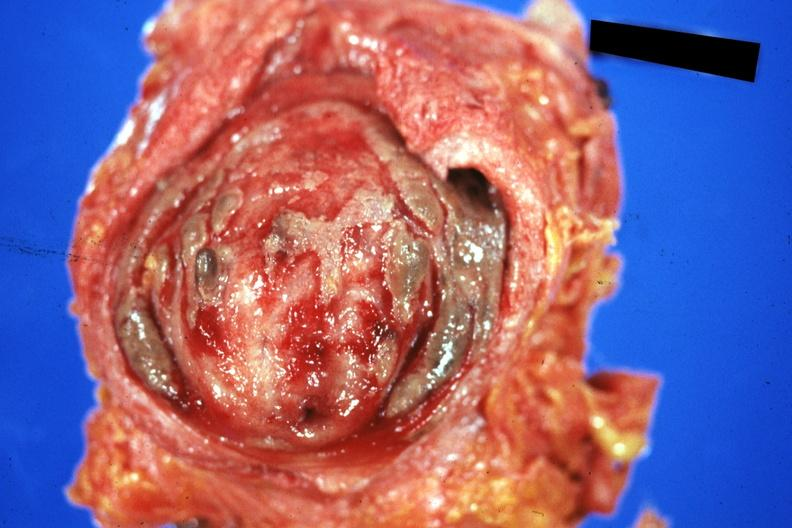what is present?
Answer the question using a single word or phrase. Urinary 